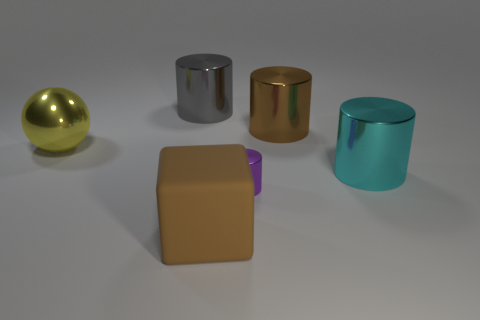Subtract all cyan cylinders. How many cylinders are left? 3 Add 2 large brown cylinders. How many objects exist? 8 Subtract all brown cylinders. How many cylinders are left? 3 Subtract all blocks. How many objects are left? 5 Subtract all brown spheres. Subtract all gray cylinders. How many spheres are left? 1 Subtract all cubes. Subtract all gray cylinders. How many objects are left? 4 Add 4 metal things. How many metal things are left? 9 Add 1 brown matte objects. How many brown matte objects exist? 2 Subtract 0 red cylinders. How many objects are left? 6 